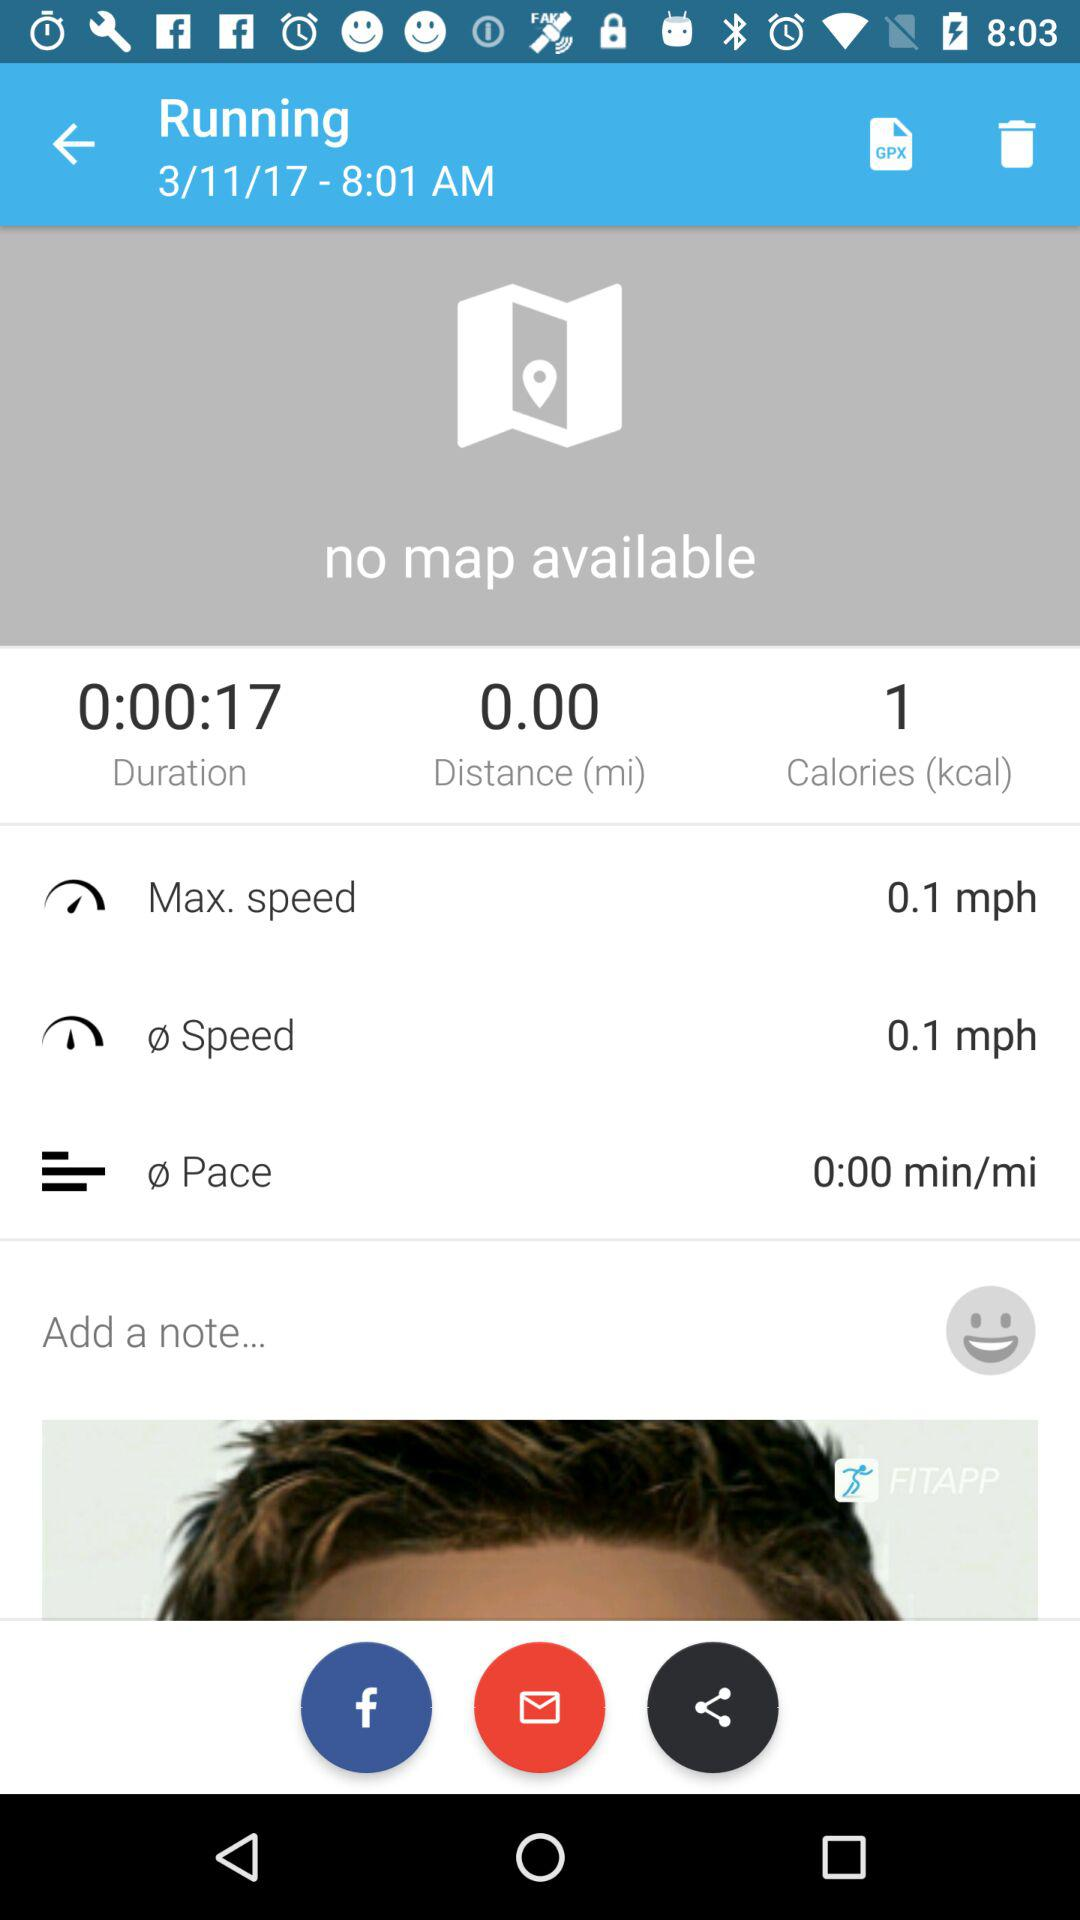What is the total time of the activity?
Answer the question using a single word or phrase. 0:000:17 